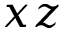Convert formula to latex. <formula><loc_0><loc_0><loc_500><loc_500>x z</formula> 